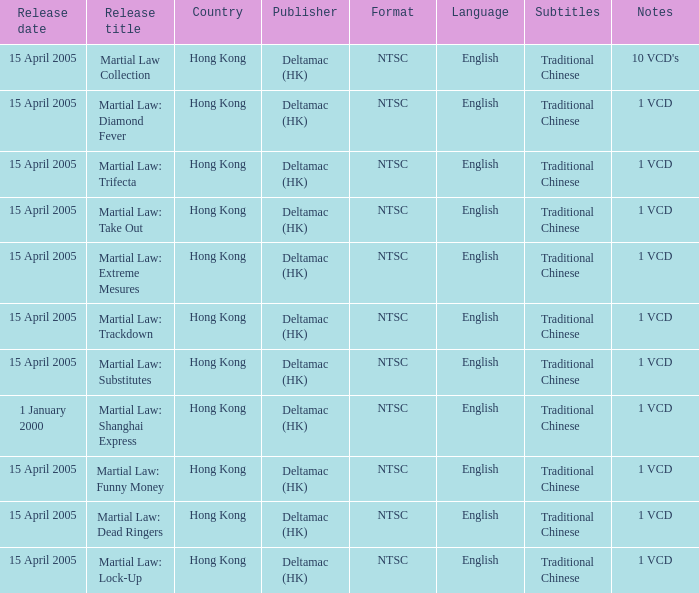Who was the publisher of Martial Law: Dead Ringers? Deltamac (HK). 